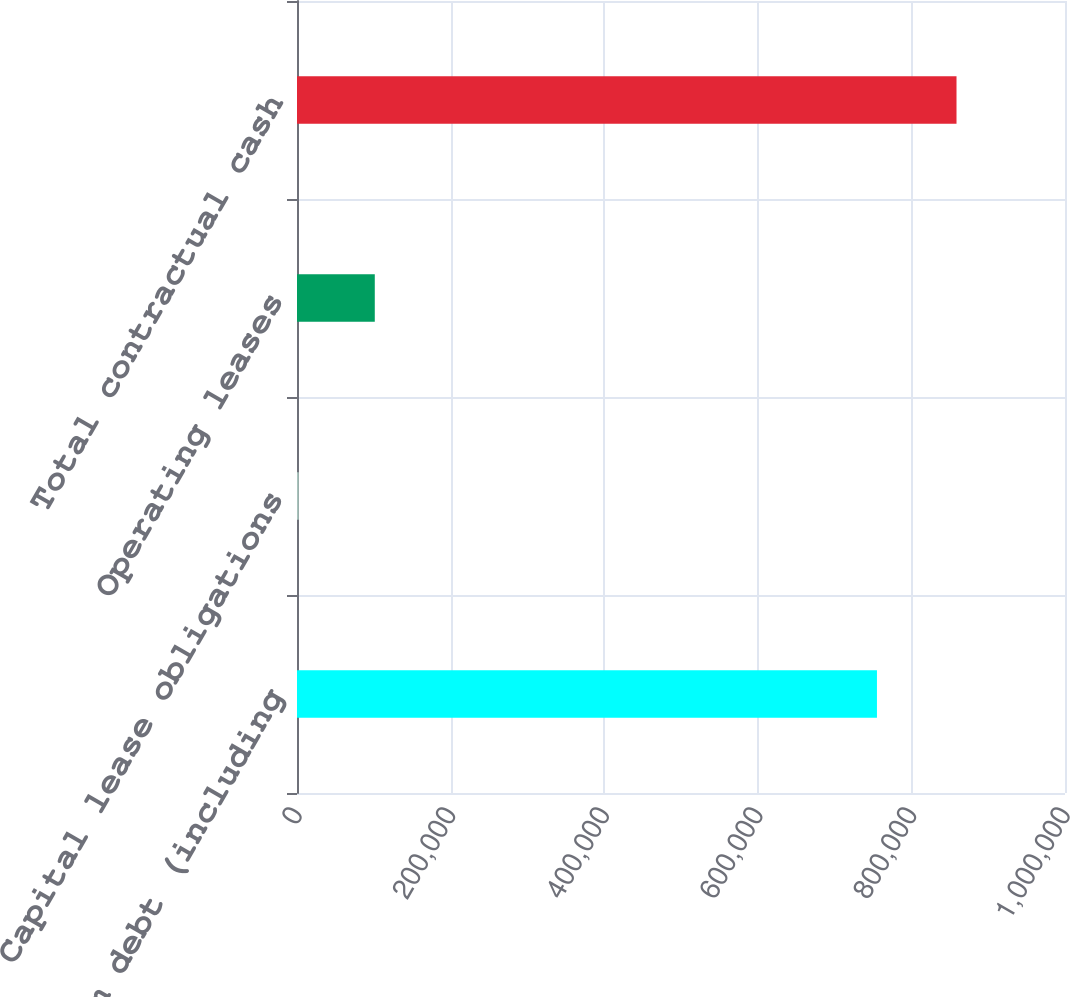Convert chart to OTSL. <chart><loc_0><loc_0><loc_500><loc_500><bar_chart><fcel>Long-term debt (including<fcel>Capital lease obligations<fcel>Operating leases<fcel>Total contractual cash<nl><fcel>755156<fcel>2299<fcel>101286<fcel>858741<nl></chart> 